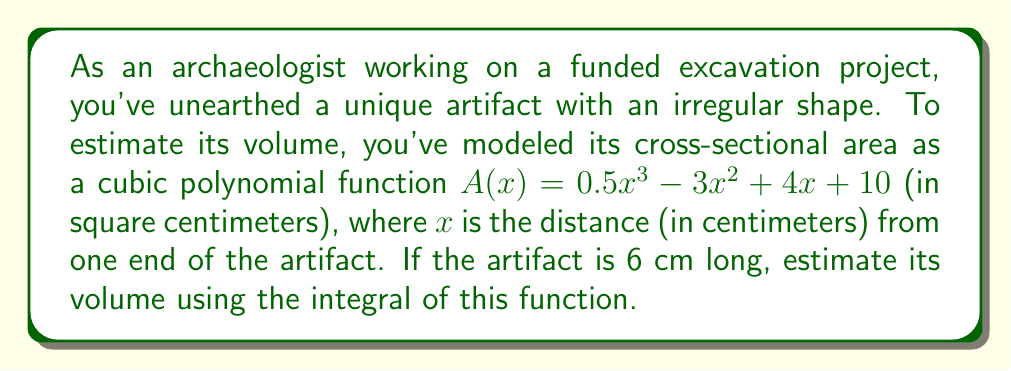Give your solution to this math problem. To estimate the volume of the artifact, we need to integrate the cross-sectional area function over the length of the artifact. This is because the volume of a solid can be found by integrating its cross-sectional area over its length.

1) The volume V is given by the definite integral:

   $$V = \int_0^6 A(x) dx$$

2) Substituting the given function:

   $$V = \int_0^6 (0.5x^3 - 3x^2 + 4x + 10) dx$$

3) Integrate each term:

   $$V = \left[ \frac{0.5x^4}{4} - x^3 + 2x^2 + 10x \right]_0^6$$

4) Evaluate the integral at the upper and lower bounds:

   $$V = \left(\frac{0.5(6^4)}{4} - 6^3 + 2(6^2) + 10(6)\right) - \left(\frac{0.5(0^4)}{4} - 0^3 + 2(0^2) + 10(0)\right)$$

5) Simplify:

   $$V = (162 - 216 + 72 + 60) - (0)$$
   $$V = 78$$

Therefore, the estimated volume of the artifact is 78 cubic centimeters.
Answer: 78 cubic centimeters 